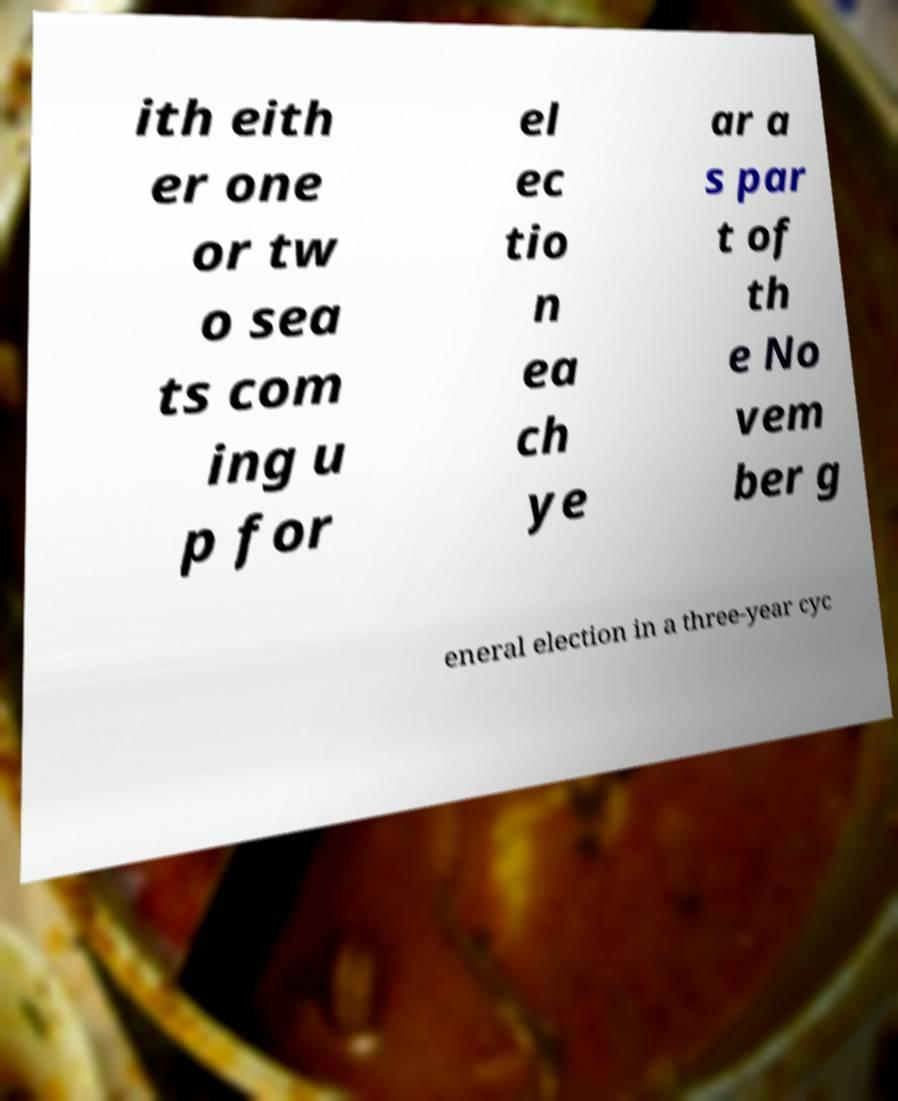Can you accurately transcribe the text from the provided image for me? ith eith er one or tw o sea ts com ing u p for el ec tio n ea ch ye ar a s par t of th e No vem ber g eneral election in a three-year cyc 